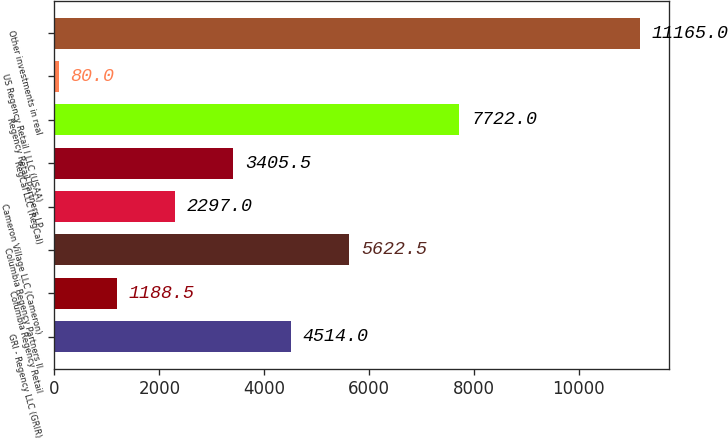<chart> <loc_0><loc_0><loc_500><loc_500><bar_chart><fcel>GRI - Regency LLC (GRIR)<fcel>Columbia Regency Retail<fcel>Columbia Regency Partners II<fcel>Cameron Village LLC (Cameron)<fcel>RegCal LLC (RegCal)<fcel>Regency Retail Partners LP<fcel>US Regency Retail I LLC (USAA)<fcel>Other investments in real<nl><fcel>4514<fcel>1188.5<fcel>5622.5<fcel>2297<fcel>3405.5<fcel>7722<fcel>80<fcel>11165<nl></chart> 